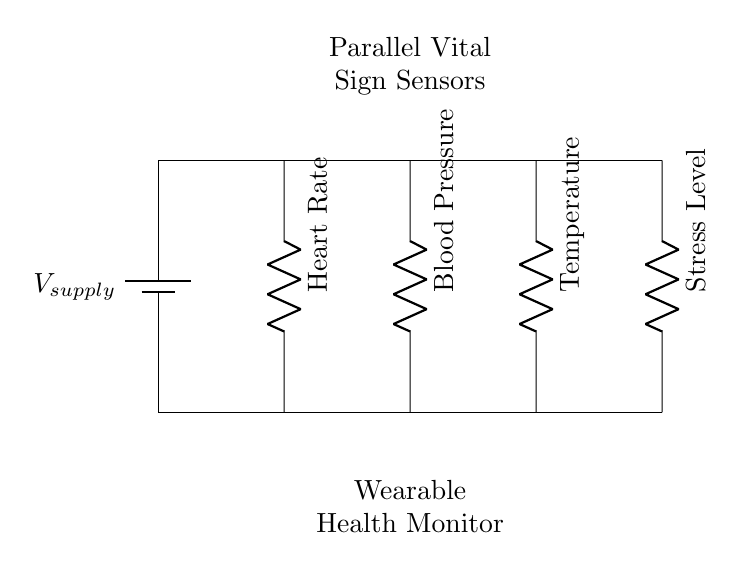What type of circuit is depicted in the diagram? The circuit shown is a parallel circuit, as indicated by the multiple components connected alongside each other, sharing the same voltage across them.
Answer: Parallel How many vital sign sensors are included? There are four vital sign sensors in the circuit: heart rate, blood pressure, temperature, and stress level. They are represented by separate resistors connected in parallel.
Answer: Four What is the purpose of the battery in the circuit? The battery provides the necessary supply voltage for the circuit, ensuring all sensors operate correctly by delivering power throughout the parallel connections.
Answer: Supply voltage What happens to the total current if one sensor fails? In a parallel circuit, if one sensor fails, the total current will still flow through the other sensors. This means the overall function of the health monitor remains operational despite one component malfunctioning.
Answer: Remains operational Which vital sign sensor is represented on the leftmost side? The sensor on the leftmost side is the heart rate sensor, as indicated in the circuit label.
Answer: Heart Rate How does the voltage compare across all sensors? In a parallel circuit, the voltage across each sensor is equal to the supply voltage; therefore, all sensors receive the same voltage.
Answer: Equal to supply voltage What is the significance of having a parallel arrangement for these sensors? A parallel arrangement allows multiple vital signs to be monitored simultaneously without affecting one another's functioning, which is crucial in a wearable health monitor during recovery.
Answer: Simultaneous monitoring 